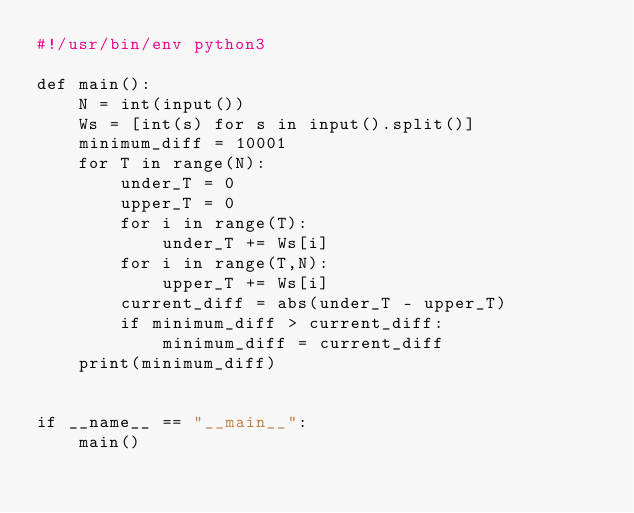<code> <loc_0><loc_0><loc_500><loc_500><_Python_>#!/usr/bin/env python3

def main():
    N = int(input())
    Ws = [int(s) for s in input().split()]
    minimum_diff = 10001
    for T in range(N):
        under_T = 0
        upper_T = 0
        for i in range(T):
            under_T += Ws[i]
        for i in range(T,N):
            upper_T += Ws[i]
        current_diff = abs(under_T - upper_T)
        if minimum_diff > current_diff:
            minimum_diff = current_diff
    print(minimum_diff)


if __name__ == "__main__":
    main()
</code> 